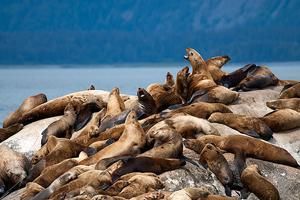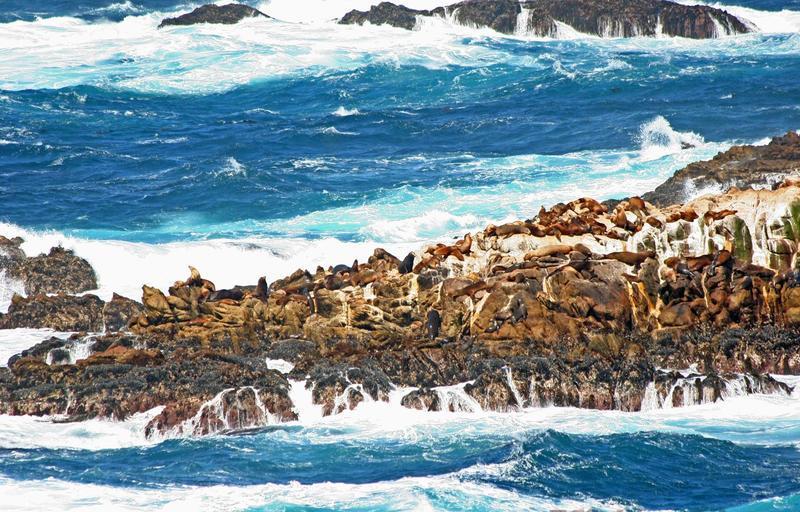The first image is the image on the left, the second image is the image on the right. Examine the images to the left and right. Is the description "There is no land on the horizon of the image on the left." accurate? Answer yes or no. No. 